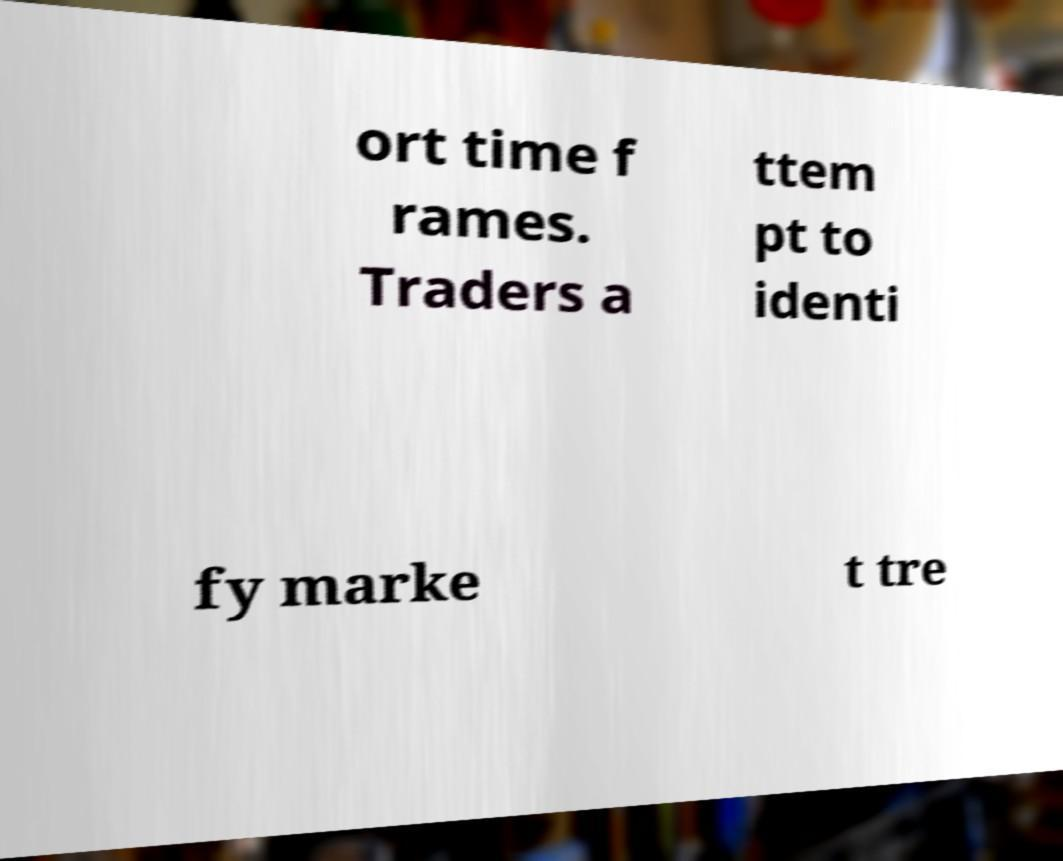Can you accurately transcribe the text from the provided image for me? ort time f rames. Traders a ttem pt to identi fy marke t tre 